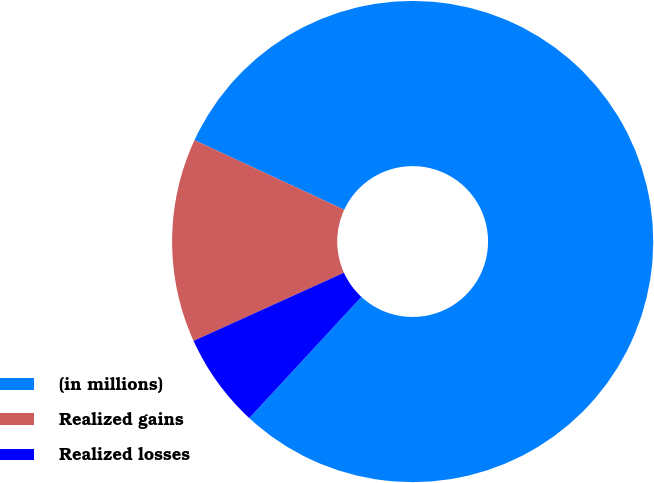<chart> <loc_0><loc_0><loc_500><loc_500><pie_chart><fcel>(in millions)<fcel>Realized gains<fcel>Realized losses<nl><fcel>79.95%<fcel>13.7%<fcel>6.34%<nl></chart> 